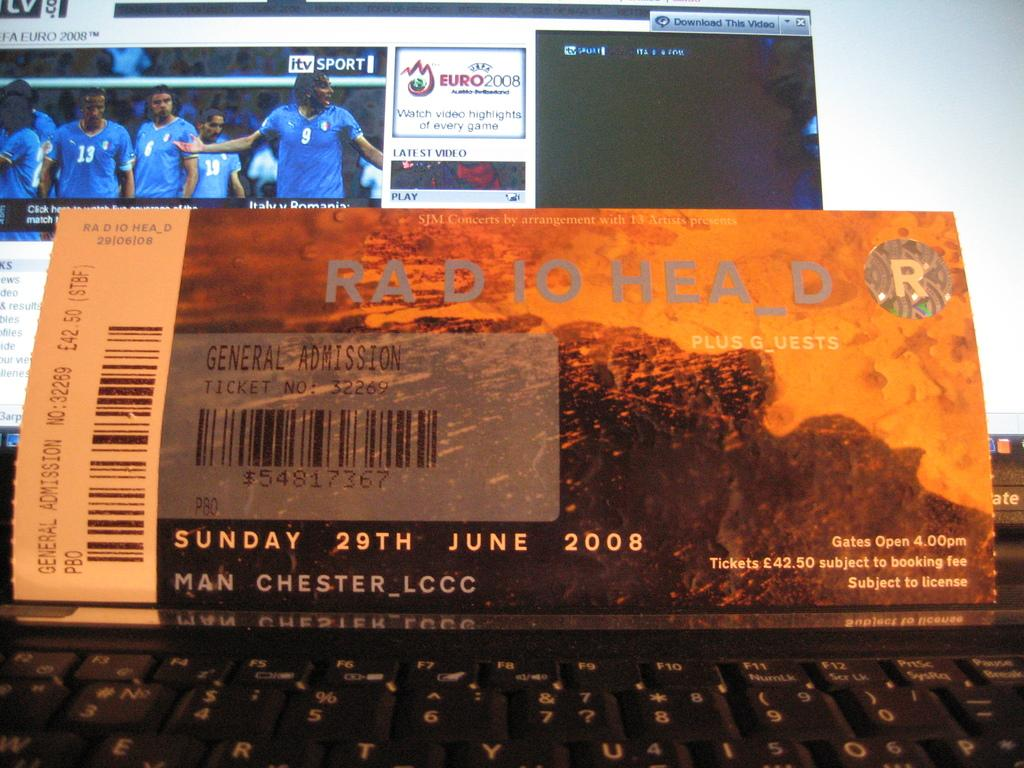<image>
Relay a brief, clear account of the picture shown. Ticket for Radio Head resting on top of a black keyboard. 